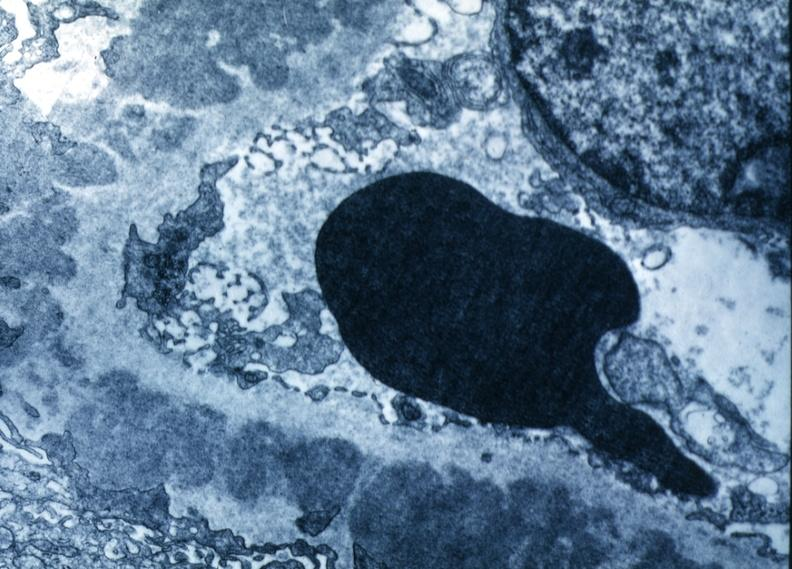what is present?
Answer the question using a single word or phrase. Kidney 